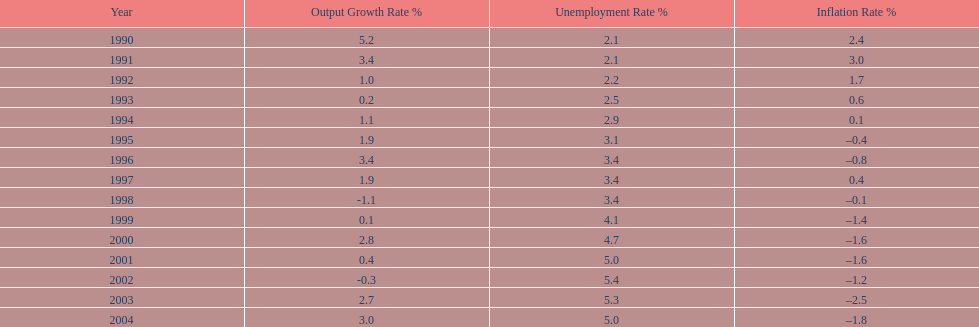During which year was the maximum unemployment rate recorded? 2002. 